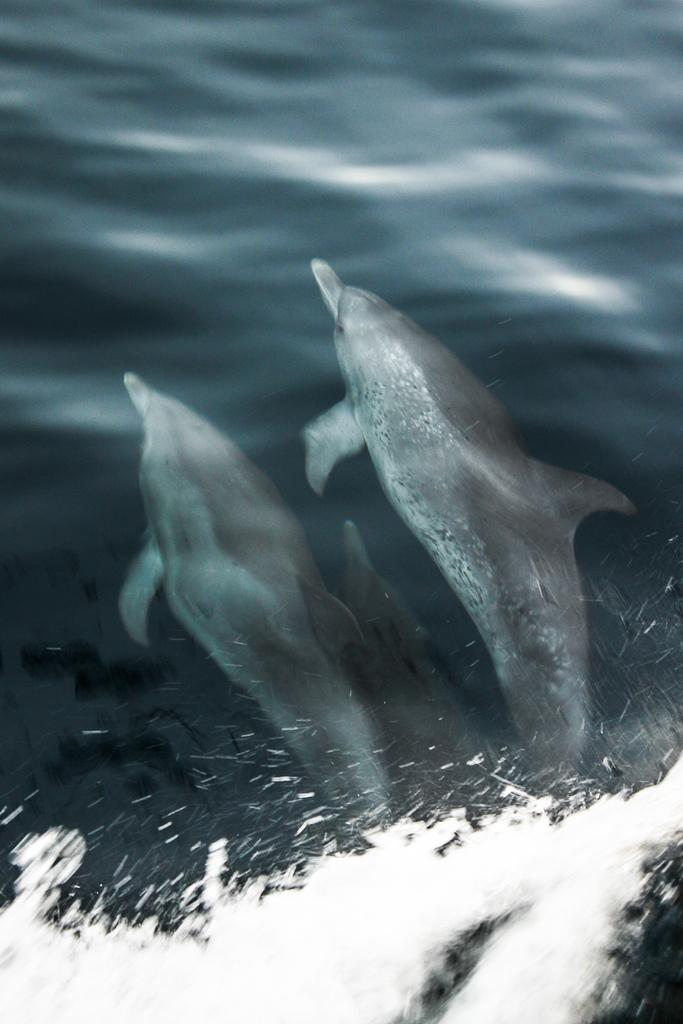What type of body of water is visible in the image? There is a sea in the image. Are there any animals present in the sea? Yes, there are two dolphins in the sea. Can you see any planes flying over the sea in the image? There is no plane visible in the image; it only features a sea with two dolphins. Are there any toes visible in the image? There are no toes present in the image; it only features a sea with two dolphins. 